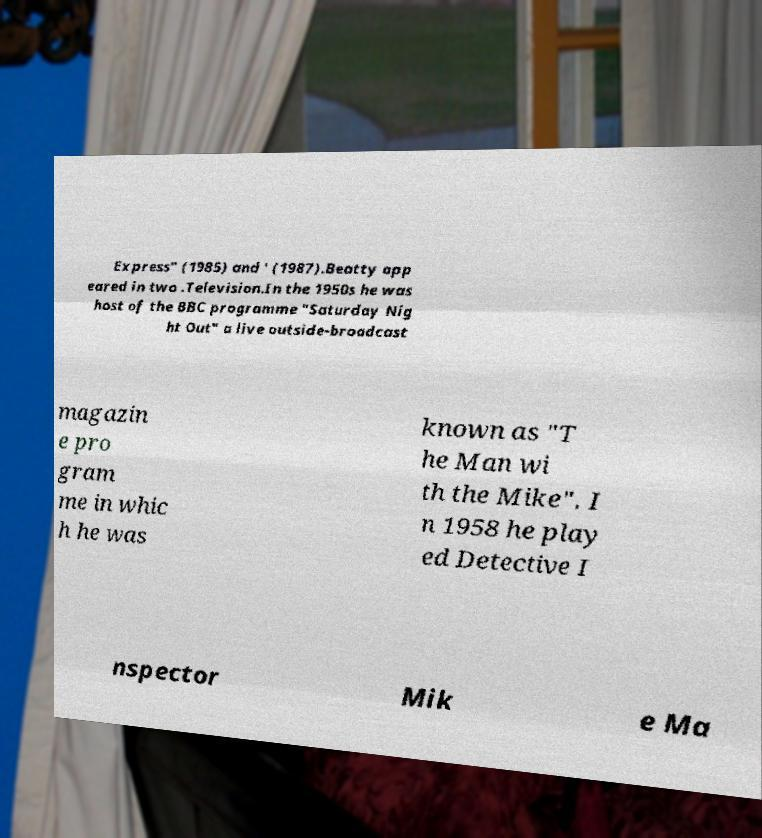Could you assist in decoding the text presented in this image and type it out clearly? Express" (1985) and ' (1987).Beatty app eared in two .Television.In the 1950s he was host of the BBC programme "Saturday Nig ht Out" a live outside-broadcast magazin e pro gram me in whic h he was known as "T he Man wi th the Mike". I n 1958 he play ed Detective I nspector Mik e Ma 